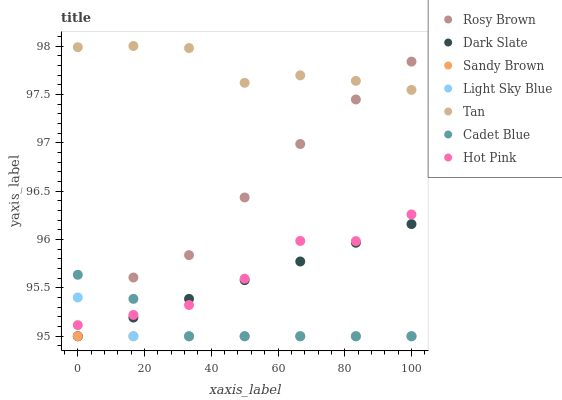Does Sandy Brown have the minimum area under the curve?
Answer yes or no. Yes. Does Tan have the maximum area under the curve?
Answer yes or no. Yes. Does Rosy Brown have the minimum area under the curve?
Answer yes or no. No. Does Rosy Brown have the maximum area under the curve?
Answer yes or no. No. Is Sandy Brown the smoothest?
Answer yes or no. Yes. Is Tan the roughest?
Answer yes or no. Yes. Is Rosy Brown the smoothest?
Answer yes or no. No. Is Rosy Brown the roughest?
Answer yes or no. No. Does Cadet Blue have the lowest value?
Answer yes or no. Yes. Does Hot Pink have the lowest value?
Answer yes or no. No. Does Tan have the highest value?
Answer yes or no. Yes. Does Rosy Brown have the highest value?
Answer yes or no. No. Is Sandy Brown less than Tan?
Answer yes or no. Yes. Is Tan greater than Dark Slate?
Answer yes or no. Yes. Does Dark Slate intersect Sandy Brown?
Answer yes or no. Yes. Is Dark Slate less than Sandy Brown?
Answer yes or no. No. Is Dark Slate greater than Sandy Brown?
Answer yes or no. No. Does Sandy Brown intersect Tan?
Answer yes or no. No. 